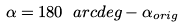Convert formula to latex. <formula><loc_0><loc_0><loc_500><loc_500>\alpha = 1 8 0 \ a r c d e g - \alpha _ { o r i g }</formula> 